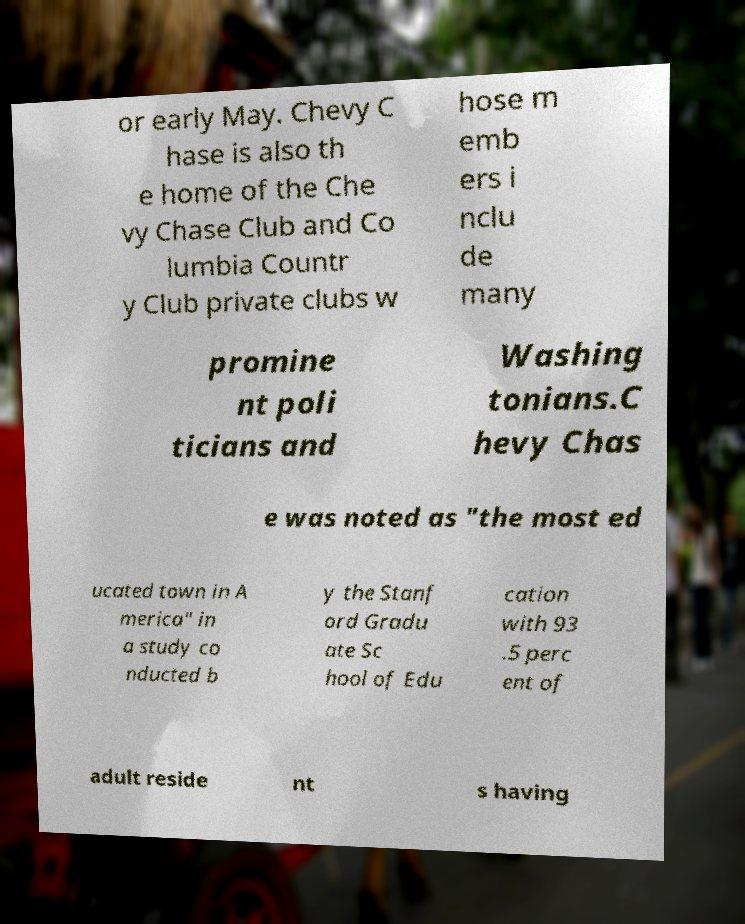For documentation purposes, I need the text within this image transcribed. Could you provide that? or early May. Chevy C hase is also th e home of the Che vy Chase Club and Co lumbia Countr y Club private clubs w hose m emb ers i nclu de many promine nt poli ticians and Washing tonians.C hevy Chas e was noted as "the most ed ucated town in A merica" in a study co nducted b y the Stanf ord Gradu ate Sc hool of Edu cation with 93 .5 perc ent of adult reside nt s having 